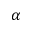Convert formula to latex. <formula><loc_0><loc_0><loc_500><loc_500>\alpha</formula> 